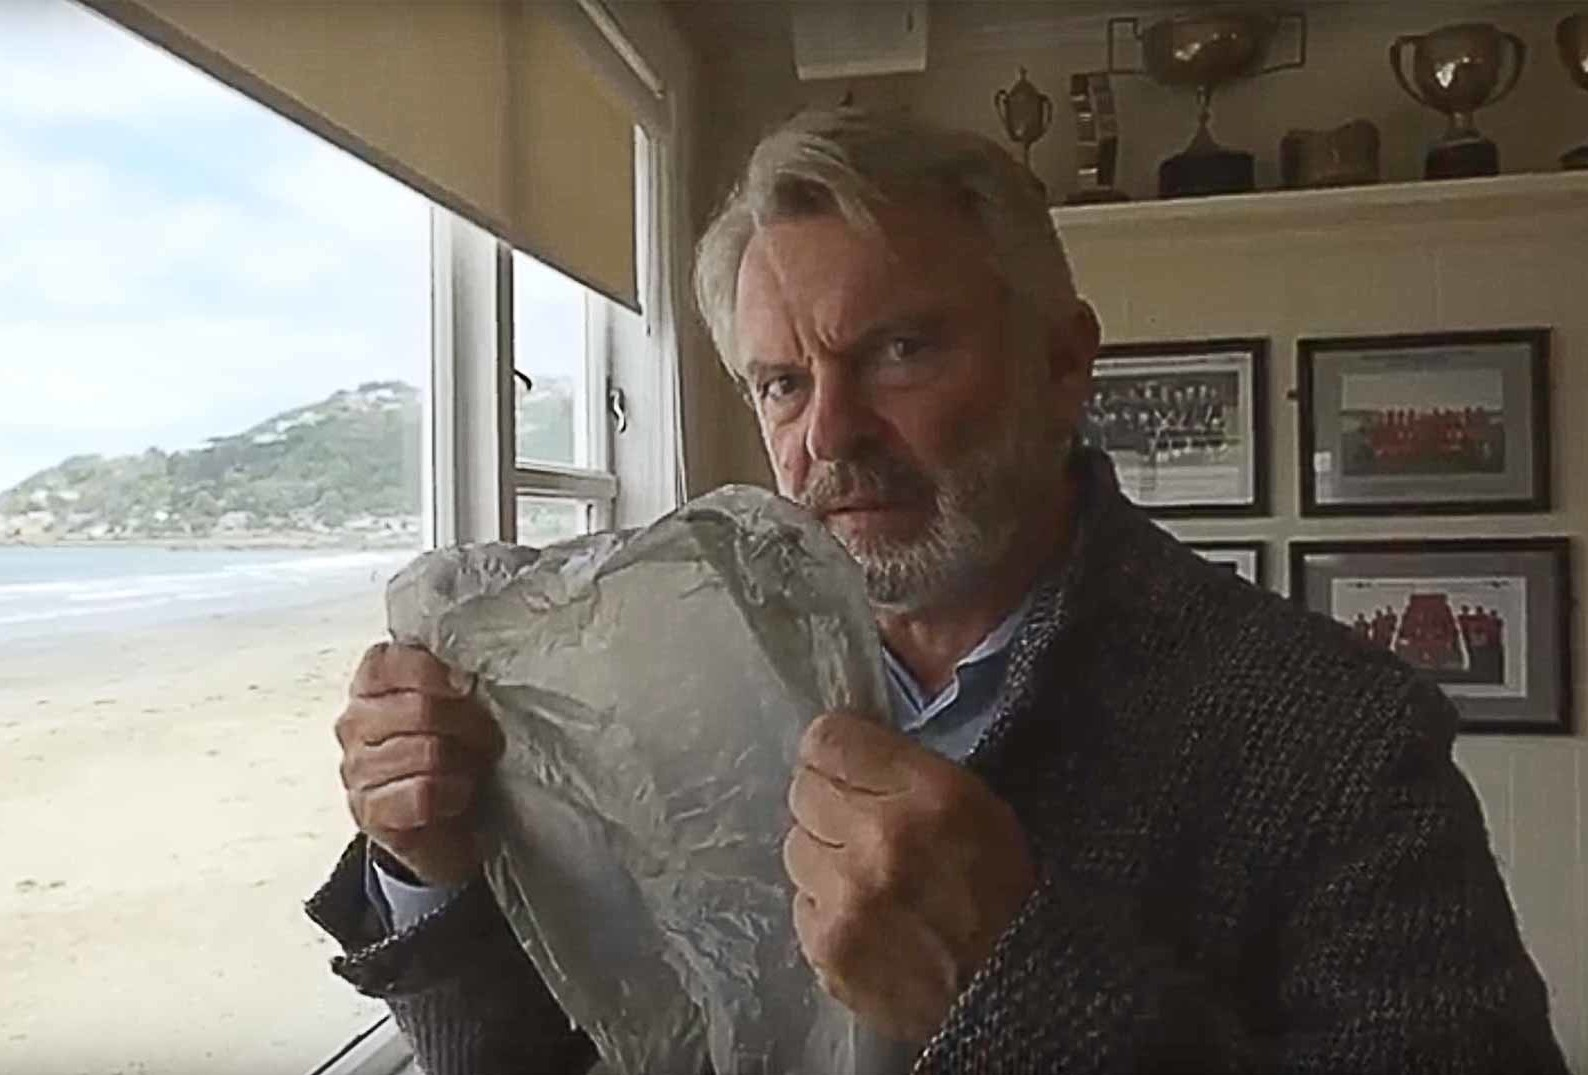What does his expression tell us about his mood or thoughts? The man's expression in the image is serious and introspective. His focused gaze and the firm grip on the foil could suggest he is deeply engrossed in his thoughts, possibly contemplating something of personal or professional importance. The intensity of his expression might indicate concern, concentration, or a moment of decision-making. 